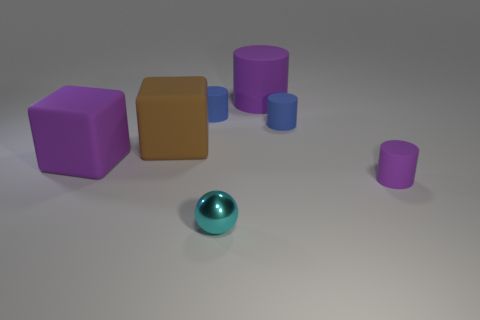There is a large matte object on the right side of the small metal ball; is it the same color as the block that is on the left side of the big brown thing?
Provide a short and direct response. Yes. How many things are yellow blocks or big cubes?
Make the answer very short. 2. What shape is the big thing that is the same color as the big matte cylinder?
Your answer should be very brief. Cube. What size is the purple matte thing that is both in front of the large cylinder and right of the big brown matte object?
Offer a terse response. Small. How many tiny purple rubber cylinders are there?
Your response must be concise. 1. What number of cubes are small cyan objects or small purple matte objects?
Provide a short and direct response. 0. How many tiny blue rubber cylinders are in front of the purple thing that is to the right of the tiny blue matte cylinder that is to the right of the tiny cyan metal sphere?
Your answer should be compact. 0. There is a matte cylinder that is the same size as the purple cube; what color is it?
Provide a short and direct response. Purple. How many other objects are the same color as the large cylinder?
Your response must be concise. 2. Is the number of big matte objects behind the small purple matte thing greater than the number of large purple matte cylinders?
Offer a very short reply. Yes. 